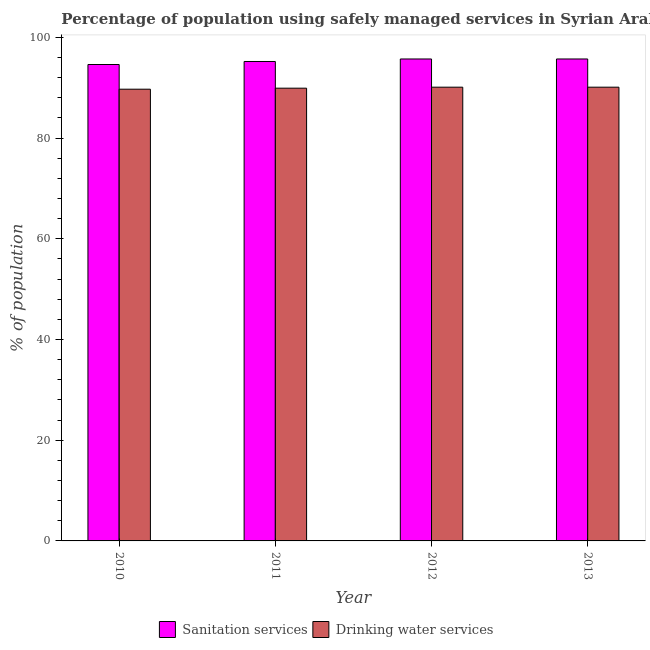How many groups of bars are there?
Give a very brief answer. 4. Are the number of bars on each tick of the X-axis equal?
Offer a terse response. Yes. How many bars are there on the 2nd tick from the left?
Offer a very short reply. 2. What is the percentage of population who used sanitation services in 2010?
Offer a very short reply. 94.6. Across all years, what is the maximum percentage of population who used drinking water services?
Offer a very short reply. 90.1. Across all years, what is the minimum percentage of population who used drinking water services?
Ensure brevity in your answer.  89.7. In which year was the percentage of population who used drinking water services maximum?
Ensure brevity in your answer.  2012. What is the total percentage of population who used sanitation services in the graph?
Provide a succinct answer. 381.2. What is the difference between the percentage of population who used sanitation services in 2012 and the percentage of population who used drinking water services in 2011?
Provide a short and direct response. 0.5. What is the average percentage of population who used sanitation services per year?
Offer a terse response. 95.3. What is the ratio of the percentage of population who used drinking water services in 2012 to that in 2013?
Provide a succinct answer. 1. What is the difference between the highest and the lowest percentage of population who used sanitation services?
Your answer should be compact. 1.1. Is the sum of the percentage of population who used sanitation services in 2011 and 2012 greater than the maximum percentage of population who used drinking water services across all years?
Offer a terse response. Yes. What does the 2nd bar from the left in 2013 represents?
Make the answer very short. Drinking water services. What does the 2nd bar from the right in 2012 represents?
Provide a short and direct response. Sanitation services. Are all the bars in the graph horizontal?
Your response must be concise. No. Are the values on the major ticks of Y-axis written in scientific E-notation?
Give a very brief answer. No. Where does the legend appear in the graph?
Offer a very short reply. Bottom center. How many legend labels are there?
Provide a succinct answer. 2. How are the legend labels stacked?
Your answer should be compact. Horizontal. What is the title of the graph?
Your answer should be compact. Percentage of population using safely managed services in Syrian Arab Republic. What is the label or title of the X-axis?
Keep it short and to the point. Year. What is the label or title of the Y-axis?
Keep it short and to the point. % of population. What is the % of population in Sanitation services in 2010?
Make the answer very short. 94.6. What is the % of population in Drinking water services in 2010?
Make the answer very short. 89.7. What is the % of population in Sanitation services in 2011?
Your answer should be very brief. 95.2. What is the % of population in Drinking water services in 2011?
Your response must be concise. 89.9. What is the % of population of Sanitation services in 2012?
Give a very brief answer. 95.7. What is the % of population of Drinking water services in 2012?
Provide a succinct answer. 90.1. What is the % of population in Sanitation services in 2013?
Provide a succinct answer. 95.7. What is the % of population in Drinking water services in 2013?
Offer a very short reply. 90.1. Across all years, what is the maximum % of population of Sanitation services?
Offer a terse response. 95.7. Across all years, what is the maximum % of population of Drinking water services?
Your response must be concise. 90.1. Across all years, what is the minimum % of population of Sanitation services?
Give a very brief answer. 94.6. Across all years, what is the minimum % of population of Drinking water services?
Offer a very short reply. 89.7. What is the total % of population in Sanitation services in the graph?
Give a very brief answer. 381.2. What is the total % of population of Drinking water services in the graph?
Provide a succinct answer. 359.8. What is the difference between the % of population in Sanitation services in 2010 and that in 2012?
Provide a succinct answer. -1.1. What is the difference between the % of population of Sanitation services in 2010 and that in 2013?
Keep it short and to the point. -1.1. What is the difference between the % of population of Drinking water services in 2011 and that in 2012?
Provide a short and direct response. -0.2. What is the difference between the % of population in Sanitation services in 2010 and the % of population in Drinking water services in 2011?
Keep it short and to the point. 4.7. What is the difference between the % of population in Sanitation services in 2010 and the % of population in Drinking water services in 2012?
Keep it short and to the point. 4.5. What is the difference between the % of population of Sanitation services in 2011 and the % of population of Drinking water services in 2012?
Provide a short and direct response. 5.1. What is the difference between the % of population of Sanitation services in 2011 and the % of population of Drinking water services in 2013?
Give a very brief answer. 5.1. What is the difference between the % of population of Sanitation services in 2012 and the % of population of Drinking water services in 2013?
Keep it short and to the point. 5.6. What is the average % of population in Sanitation services per year?
Give a very brief answer. 95.3. What is the average % of population of Drinking water services per year?
Offer a very short reply. 89.95. In the year 2010, what is the difference between the % of population of Sanitation services and % of population of Drinking water services?
Ensure brevity in your answer.  4.9. In the year 2012, what is the difference between the % of population of Sanitation services and % of population of Drinking water services?
Your response must be concise. 5.6. What is the ratio of the % of population of Sanitation services in 2010 to that in 2011?
Ensure brevity in your answer.  0.99. What is the ratio of the % of population of Drinking water services in 2010 to that in 2011?
Make the answer very short. 1. What is the ratio of the % of population of Drinking water services in 2010 to that in 2012?
Give a very brief answer. 1. What is the ratio of the % of population of Drinking water services in 2010 to that in 2013?
Ensure brevity in your answer.  1. What is the ratio of the % of population of Sanitation services in 2012 to that in 2013?
Give a very brief answer. 1. What is the difference between the highest and the second highest % of population in Sanitation services?
Your answer should be very brief. 0. What is the difference between the highest and the lowest % of population of Drinking water services?
Ensure brevity in your answer.  0.4. 